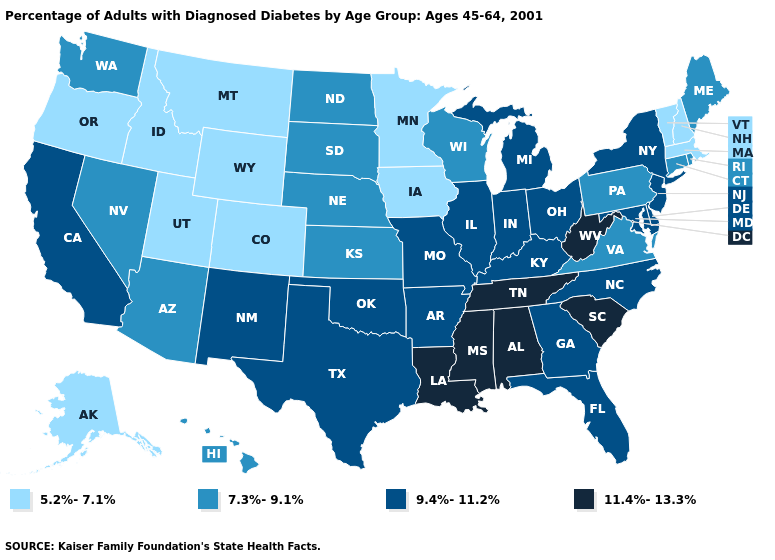Is the legend a continuous bar?
Write a very short answer. No. What is the value of Virginia?
Keep it brief. 7.3%-9.1%. Among the states that border Kansas , does Missouri have the highest value?
Give a very brief answer. Yes. Does the map have missing data?
Answer briefly. No. Does New Mexico have the highest value in the West?
Be succinct. Yes. Does Iowa have the highest value in the USA?
Answer briefly. No. Name the states that have a value in the range 11.4%-13.3%?
Keep it brief. Alabama, Louisiana, Mississippi, South Carolina, Tennessee, West Virginia. Does Hawaii have the highest value in the USA?
Be succinct. No. How many symbols are there in the legend?
Concise answer only. 4. What is the highest value in the MidWest ?
Answer briefly. 9.4%-11.2%. Name the states that have a value in the range 11.4%-13.3%?
Quick response, please. Alabama, Louisiana, Mississippi, South Carolina, Tennessee, West Virginia. What is the highest value in the USA?
Quick response, please. 11.4%-13.3%. What is the lowest value in the South?
Concise answer only. 7.3%-9.1%. What is the value of Arizona?
Write a very short answer. 7.3%-9.1%. 